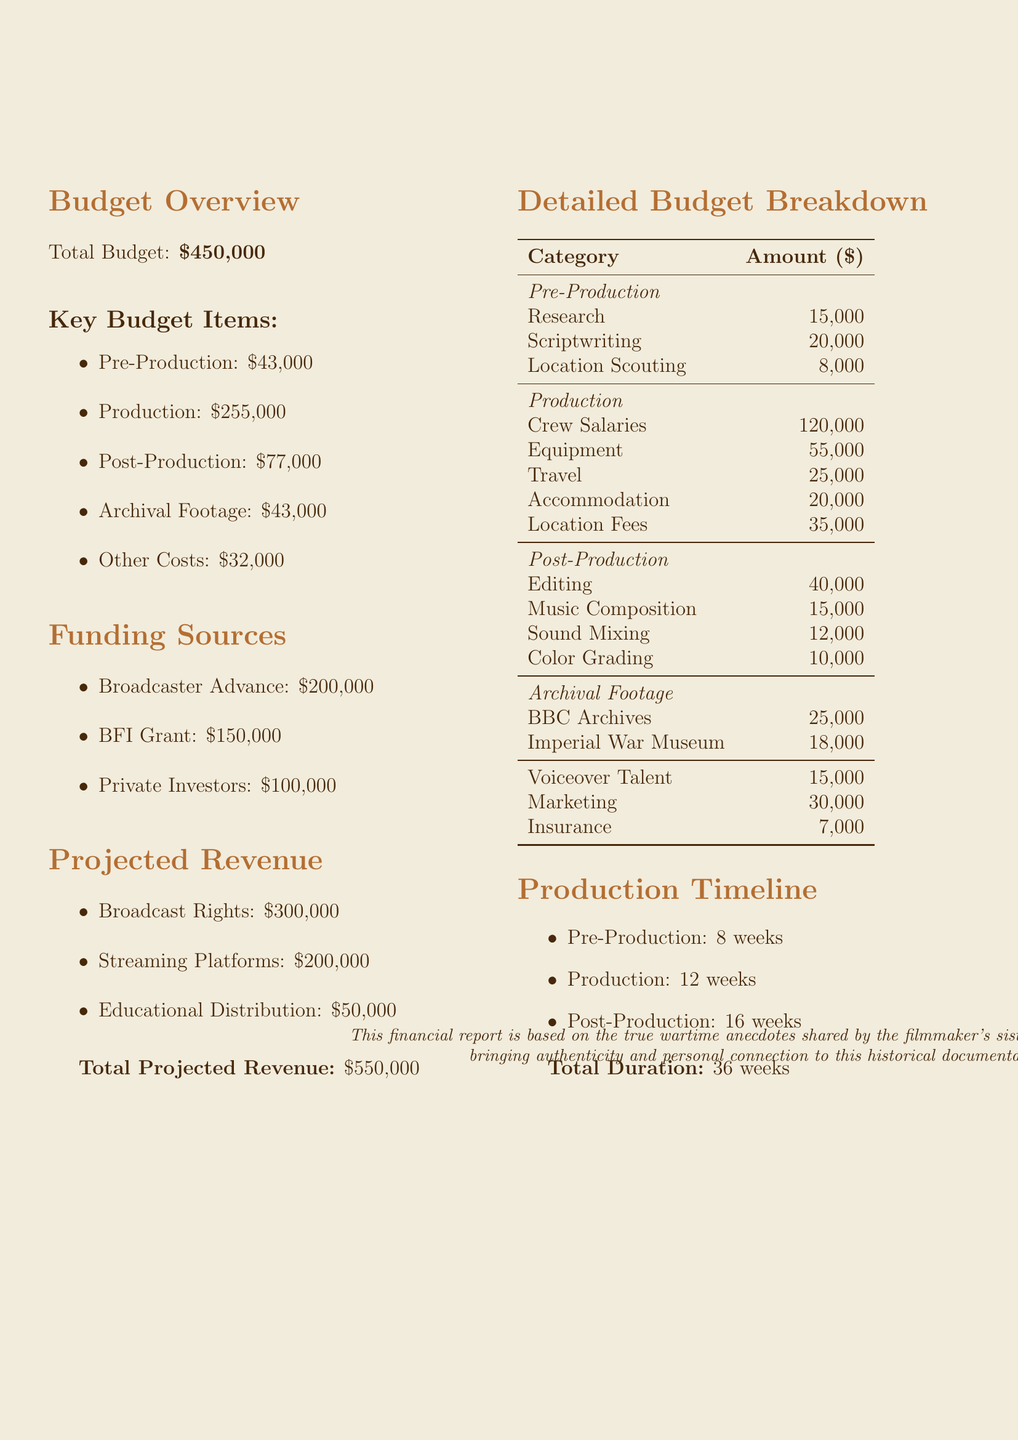What is the total budget for the documentary? The total budget is stated directly in the budget overview section.
Answer: $450,000 How much is allocated for crew salaries? The amount for crew salaries is specified in the production budget breakdown.
Answer: $120,000 What is the funding source with the highest amount? The funding source with the highest amount is detailed in the funding sources section.
Answer: Broadcaster Advance What are the total costs for pre-production? The total costs for pre-production are calculated by adding the amounts from the pre-production section.
Answer: $43,000 How many weeks are allocated for the post-production phase? The timeline for post-production is explicitly mentioned in the production timeline section.
Answer: 16 weeks What is the total projected revenue? The total projected revenue is summarized at the end of the projected revenue section.
Answer: $550,000 What percentage of the total budget is allocated to production costs? This requires calculating the proportion of the production costs relative to the total budget provided.
Answer: 56.67% Which archive is associated with the largest cost? The costs for the archival footage are specified in the archival footage section.
Answer: BBC Archives How much is allocated for marketing? The specific amount allocated for marketing is mentioned in the budget breakdown.
Answer: $30,000 